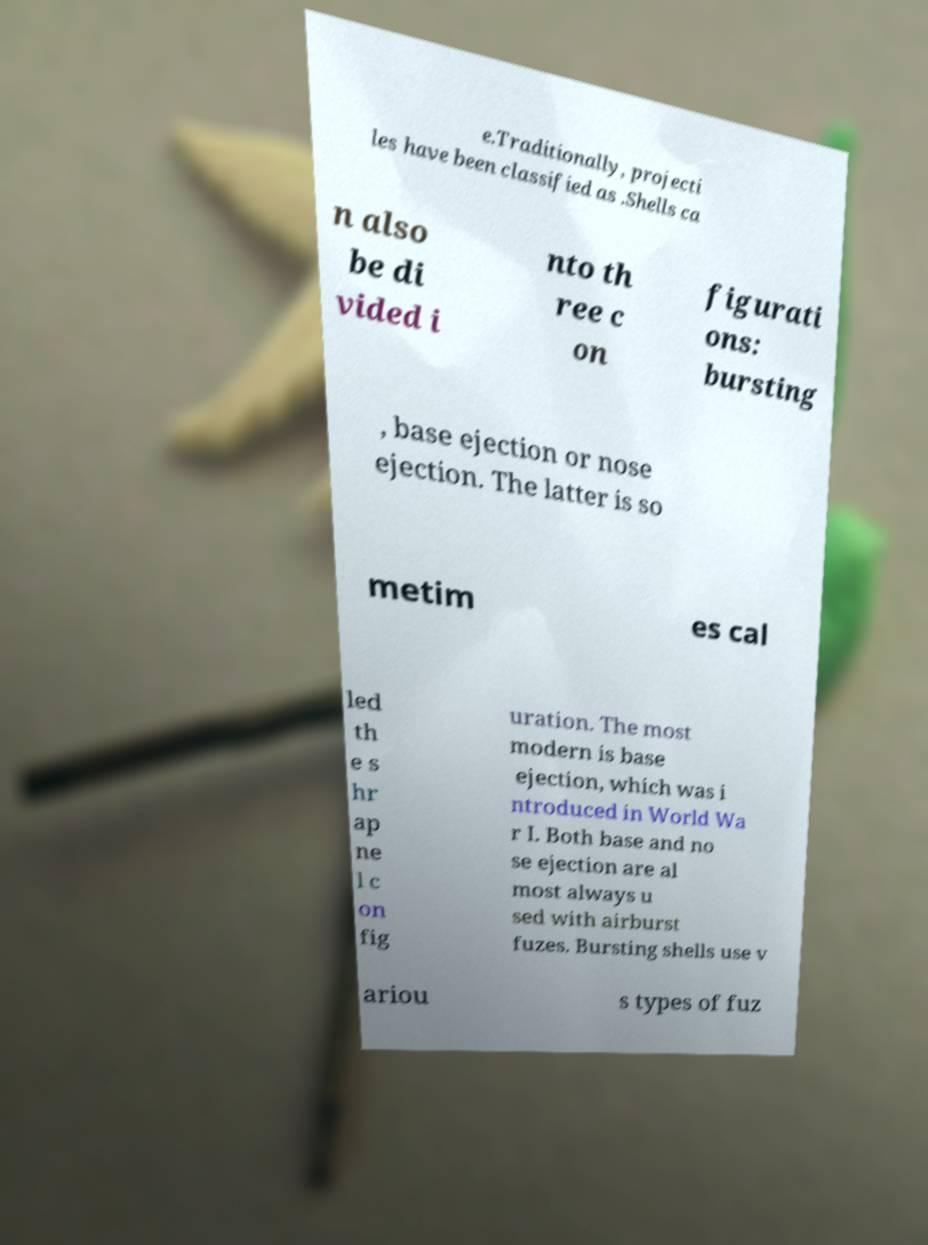Can you accurately transcribe the text from the provided image for me? e.Traditionally, projecti les have been classified as .Shells ca n also be di vided i nto th ree c on figurati ons: bursting , base ejection or nose ejection. The latter is so metim es cal led th e s hr ap ne l c on fig uration. The most modern is base ejection, which was i ntroduced in World Wa r I. Both base and no se ejection are al most always u sed with airburst fuzes. Bursting shells use v ariou s types of fuz 